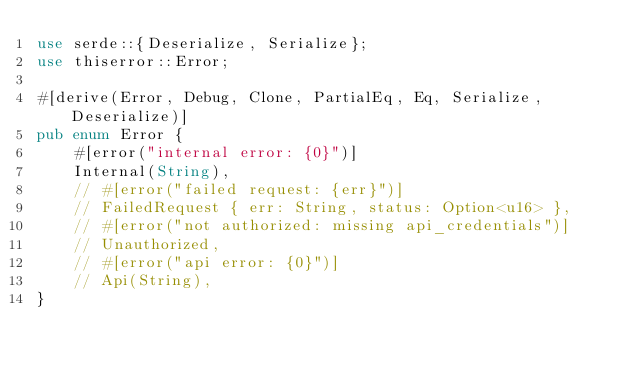Convert code to text. <code><loc_0><loc_0><loc_500><loc_500><_Rust_>use serde::{Deserialize, Serialize};
use thiserror::Error;

#[derive(Error, Debug, Clone, PartialEq, Eq, Serialize, Deserialize)]
pub enum Error {
    #[error("internal error: {0}")]
    Internal(String),
    // #[error("failed request: {err}")]
    // FailedRequest { err: String, status: Option<u16> },
    // #[error("not authorized: missing api_credentials")]
    // Unauthorized,
    // #[error("api error: {0}")]
    // Api(String),
}
</code> 